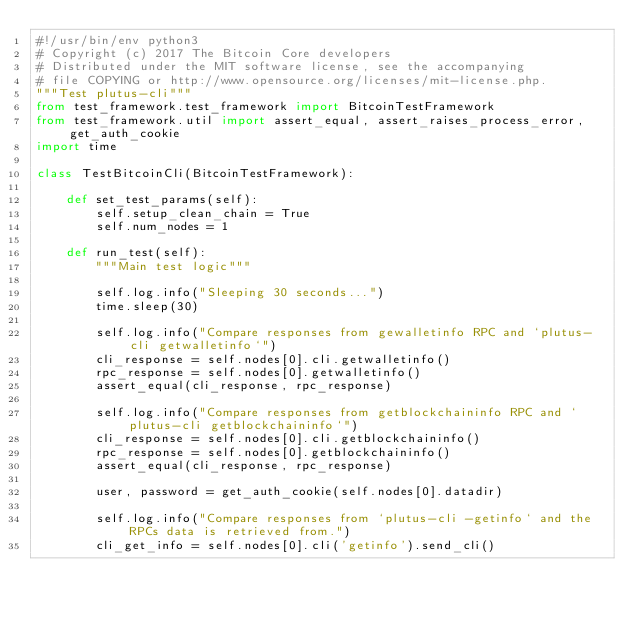<code> <loc_0><loc_0><loc_500><loc_500><_Python_>#!/usr/bin/env python3
# Copyright (c) 2017 The Bitcoin Core developers
# Distributed under the MIT software license, see the accompanying
# file COPYING or http://www.opensource.org/licenses/mit-license.php.
"""Test plutus-cli"""
from test_framework.test_framework import BitcoinTestFramework
from test_framework.util import assert_equal, assert_raises_process_error, get_auth_cookie
import time

class TestBitcoinCli(BitcoinTestFramework):

    def set_test_params(self):
        self.setup_clean_chain = True
        self.num_nodes = 1

    def run_test(self):
        """Main test logic"""

        self.log.info("Sleeping 30 seconds...")
        time.sleep(30)

        self.log.info("Compare responses from gewalletinfo RPC and `plutus-cli getwalletinfo`")
        cli_response = self.nodes[0].cli.getwalletinfo()
        rpc_response = self.nodes[0].getwalletinfo()
        assert_equal(cli_response, rpc_response)

        self.log.info("Compare responses from getblockchaininfo RPC and `plutus-cli getblockchaininfo`")
        cli_response = self.nodes[0].cli.getblockchaininfo()
        rpc_response = self.nodes[0].getblockchaininfo()
        assert_equal(cli_response, rpc_response)

        user, password = get_auth_cookie(self.nodes[0].datadir)

        self.log.info("Compare responses from `plutus-cli -getinfo` and the RPCs data is retrieved from.")
        cli_get_info = self.nodes[0].cli('getinfo').send_cli()</code> 